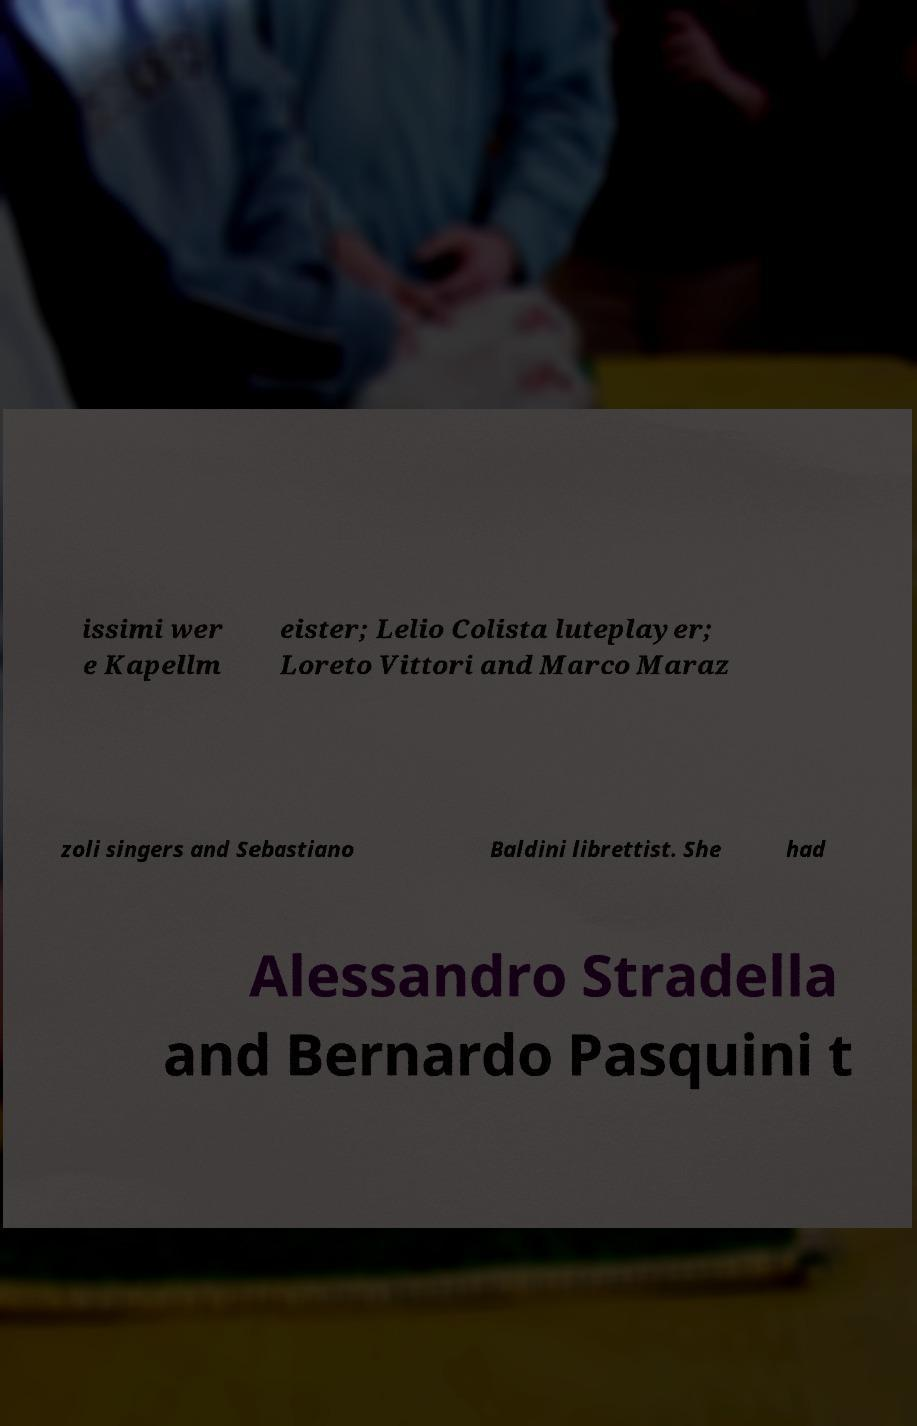Could you assist in decoding the text presented in this image and type it out clearly? issimi wer e Kapellm eister; Lelio Colista luteplayer; Loreto Vittori and Marco Maraz zoli singers and Sebastiano Baldini librettist. She had Alessandro Stradella and Bernardo Pasquini t 